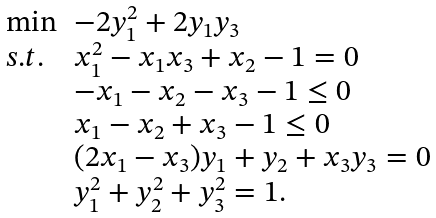<formula> <loc_0><loc_0><loc_500><loc_500>\begin{array} { l l } \min & - 2 y _ { 1 } ^ { 2 } + 2 y _ { 1 } y _ { 3 } \\ s . t . & x _ { 1 } ^ { 2 } - x _ { 1 } x _ { 3 } + x _ { 2 } - 1 = 0 \\ & - x _ { 1 } - x _ { 2 } - x _ { 3 } - 1 \leq 0 \\ & x _ { 1 } - x _ { 2 } + x _ { 3 } - 1 \leq 0 \\ & ( 2 x _ { 1 } - x _ { 3 } ) y _ { 1 } + y _ { 2 } + x _ { 3 } y _ { 3 } = 0 \\ & y _ { 1 } ^ { 2 } + y _ { 2 } ^ { 2 } + y _ { 3 } ^ { 2 } = 1 . \end{array}</formula> 